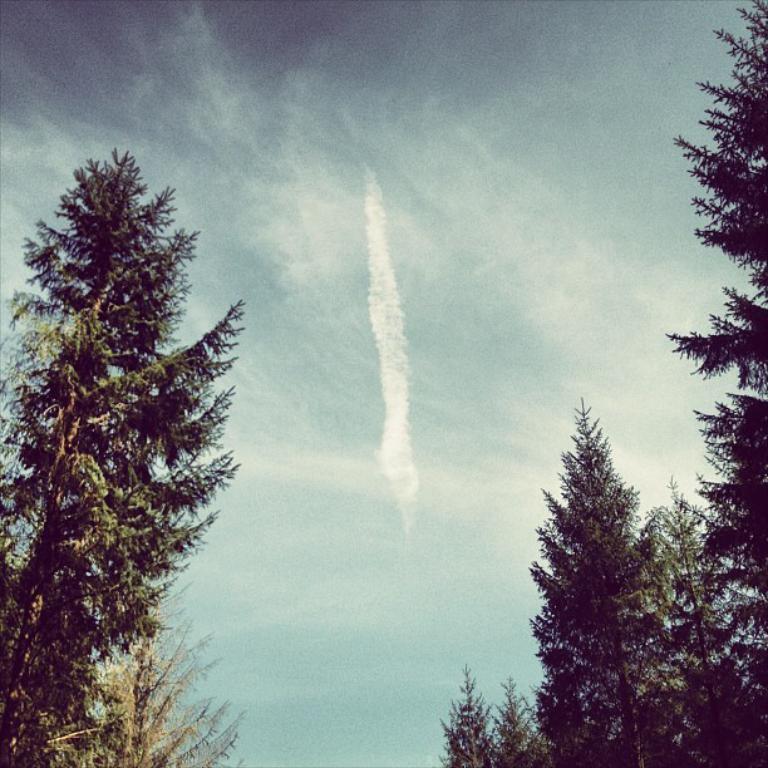Please provide a concise description of this image. In this image there are trees and the sky is cloudy. 